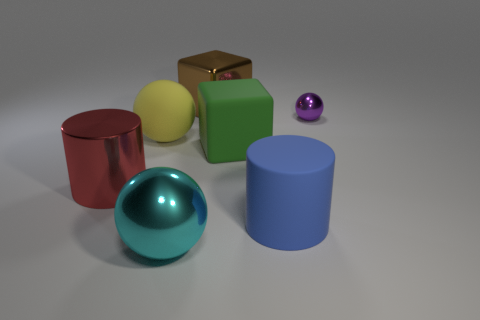How many other objects are the same material as the big green thing?
Offer a terse response. 2. There is a rubber cube; does it have the same size as the shiny object to the left of the large cyan thing?
Provide a succinct answer. Yes. What is the color of the small shiny object?
Ensure brevity in your answer.  Purple. What shape is the shiny object that is on the left side of the shiny sphere in front of the large cylinder on the left side of the cyan thing?
Provide a short and direct response. Cylinder. There is a cylinder to the right of the block that is right of the brown cube; what is its material?
Your answer should be compact. Rubber. What is the shape of the red thing that is made of the same material as the tiny ball?
Provide a short and direct response. Cylinder. What number of big metal objects are in front of the big yellow matte sphere?
Your response must be concise. 2. Are there any tiny brown blocks?
Your answer should be compact. No. There is a large rubber thing left of the large thing that is behind the ball on the right side of the blue cylinder; what color is it?
Offer a very short reply. Yellow. Are there any large matte objects that are in front of the big cube to the right of the big brown metal cube?
Offer a very short reply. Yes. 